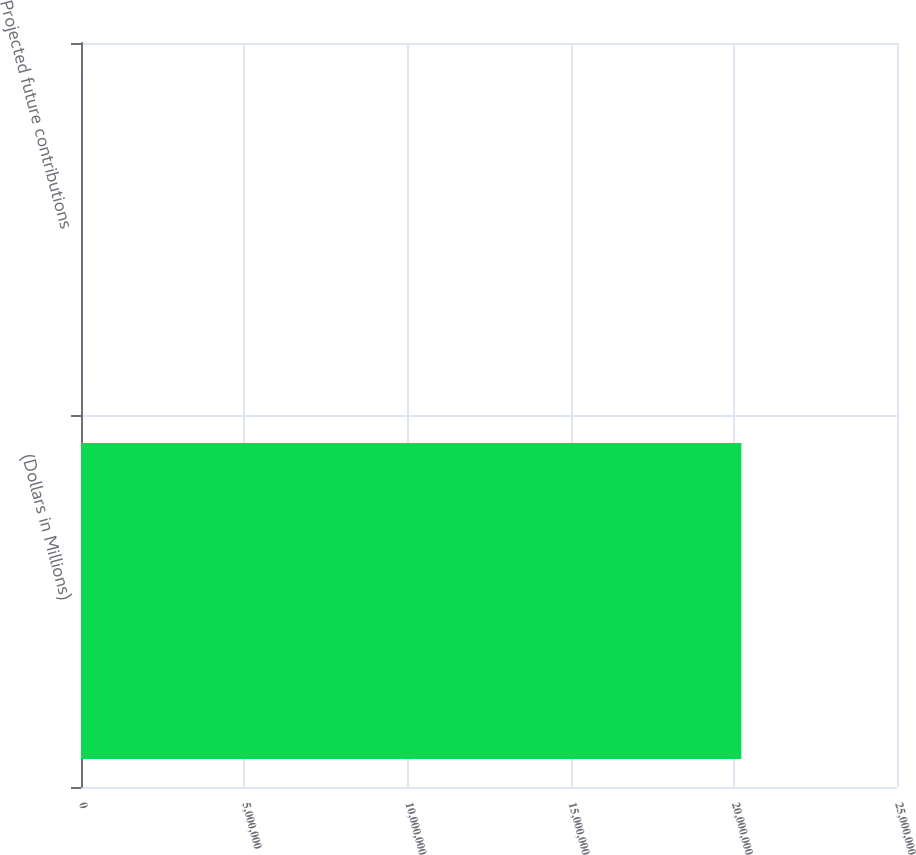<chart> <loc_0><loc_0><loc_500><loc_500><bar_chart><fcel>(Dollars in Millions)<fcel>Projected future contributions<nl><fcel>2.0232e+07<fcel>651<nl></chart> 